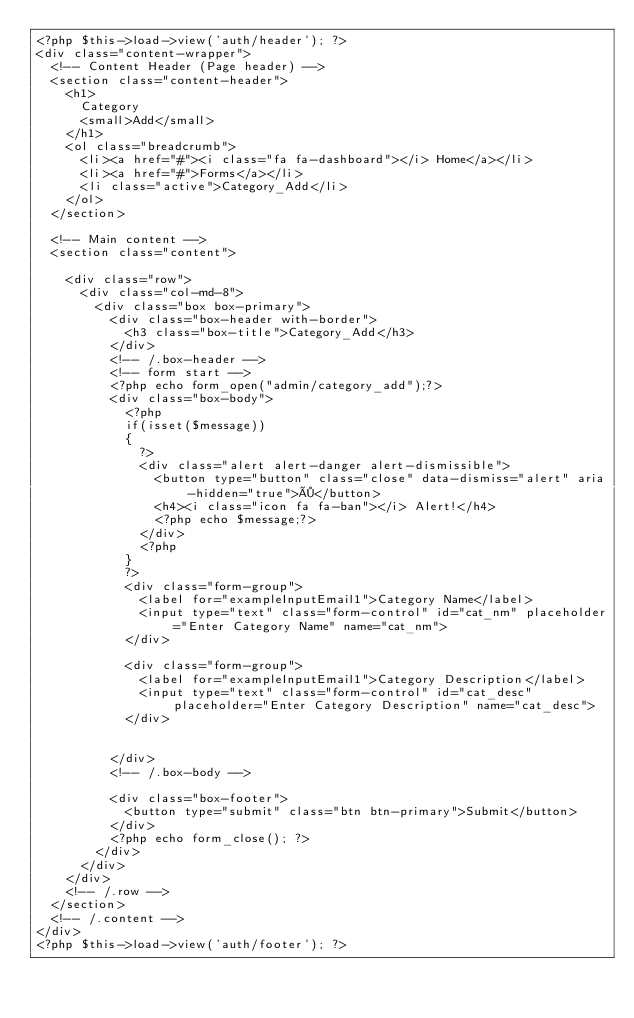Convert code to text. <code><loc_0><loc_0><loc_500><loc_500><_PHP_><?php $this->load->view('auth/header'); ?>
<div class="content-wrapper">
  <!-- Content Header (Page header) -->
  <section class="content-header">
    <h1>
      Category
      <small>Add</small>
    </h1>
    <ol class="breadcrumb">
      <li><a href="#"><i class="fa fa-dashboard"></i> Home</a></li>
      <li><a href="#">Forms</a></li>
      <li class="active">Category_Add</li>
    </ol>
  </section>

  <!-- Main content -->
  <section class="content">

    <div class="row">
      <div class="col-md-8">
        <div class="box box-primary">
          <div class="box-header with-border">
            <h3 class="box-title">Category_Add</h3>
          </div>
          <!-- /.box-header -->
          <!-- form start -->
          <?php echo form_open("admin/category_add");?>
          <div class="box-body">
            <?php
            if(isset($message))
            {
              ?>
              <div class="alert alert-danger alert-dismissible">
                <button type="button" class="close" data-dismiss="alert" aria-hidden="true">×</button>
                <h4><i class="icon fa fa-ban"></i> Alert!</h4>
                <?php echo $message;?>
              </div>
              <?php
            }
            ?>
            <div class="form-group">
              <label for="exampleInputEmail1">Category Name</label>
              <input type="text" class="form-control" id="cat_nm" placeholder="Enter Category Name" name="cat_nm">
            </div>

            <div class="form-group">
              <label for="exampleInputEmail1">Category Description</label>
              <input type="text" class="form-control" id="cat_desc" placeholder="Enter Category Description" name="cat_desc">
            </div>

            
          </div>
          <!-- /.box-body -->

          <div class="box-footer">
            <button type="submit" class="btn btn-primary">Submit</button>
          </div>
          <?php echo form_close(); ?>
        </div>
      </div>
    </div>
    <!-- /.row -->
  </section>
  <!-- /.content -->
</div>
<?php $this->load->view('auth/footer'); ?></code> 